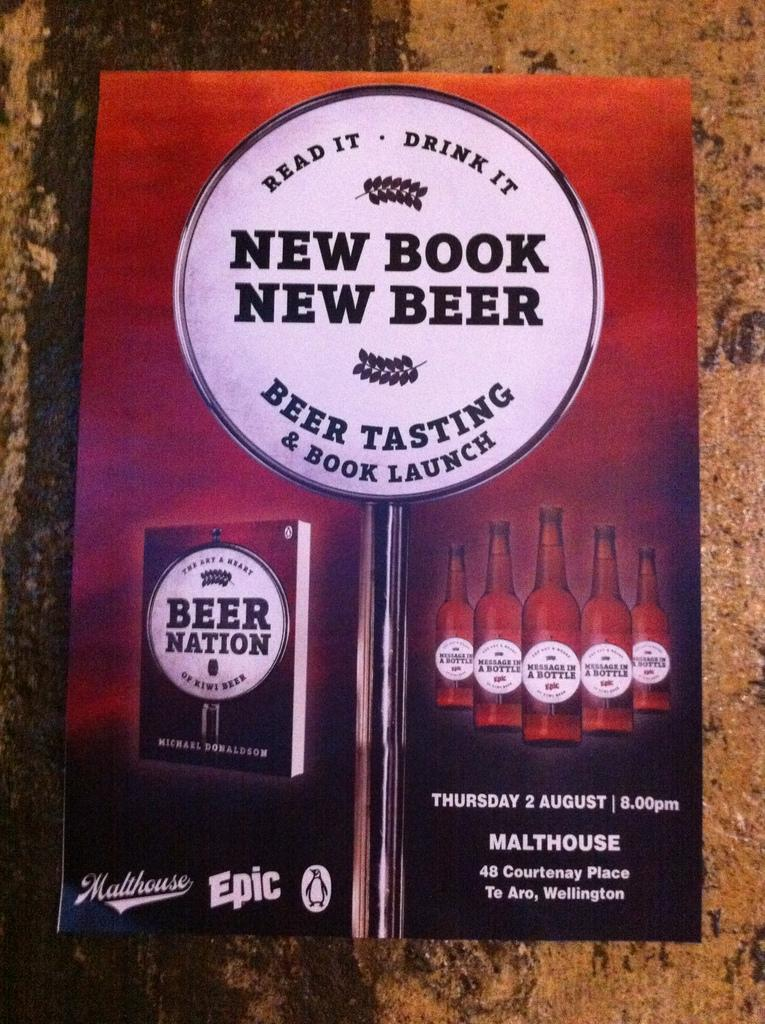Provide a one-sentence caption for the provided image. A gradient orange, brown and black poster with the writing New Book New Beer Beer tasting and Book Launch in the center and beer bottles and a book design. 